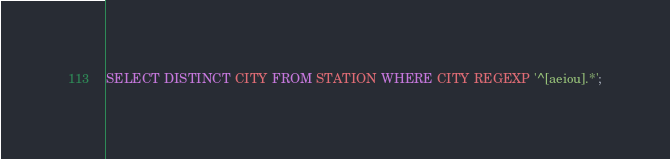Convert code to text. <code><loc_0><loc_0><loc_500><loc_500><_SQL_>SELECT DISTINCT CITY FROM STATION WHERE CITY REGEXP '^[aeiou].*';</code> 